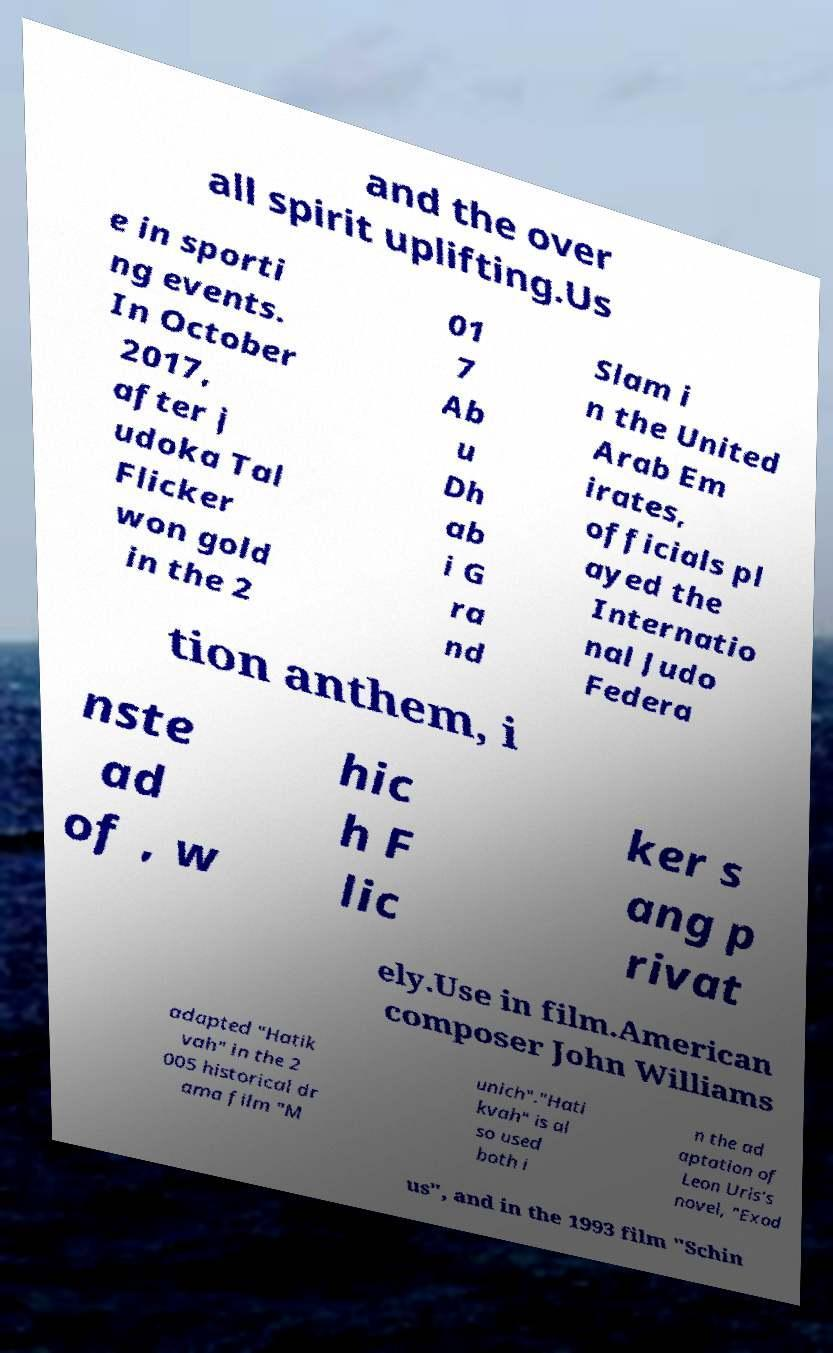I need the written content from this picture converted into text. Can you do that? and the over all spirit uplifting.Us e in sporti ng events. In October 2017, after j udoka Tal Flicker won gold in the 2 01 7 Ab u Dh ab i G ra nd Slam i n the United Arab Em irates, officials pl ayed the Internatio nal Judo Federa tion anthem, i nste ad of , w hic h F lic ker s ang p rivat ely.Use in film.American composer John Williams adapted "Hatik vah" in the 2 005 historical dr ama film "M unich"."Hati kvah" is al so used both i n the ad aptation of Leon Uris's novel, "Exod us", and in the 1993 film "Schin 